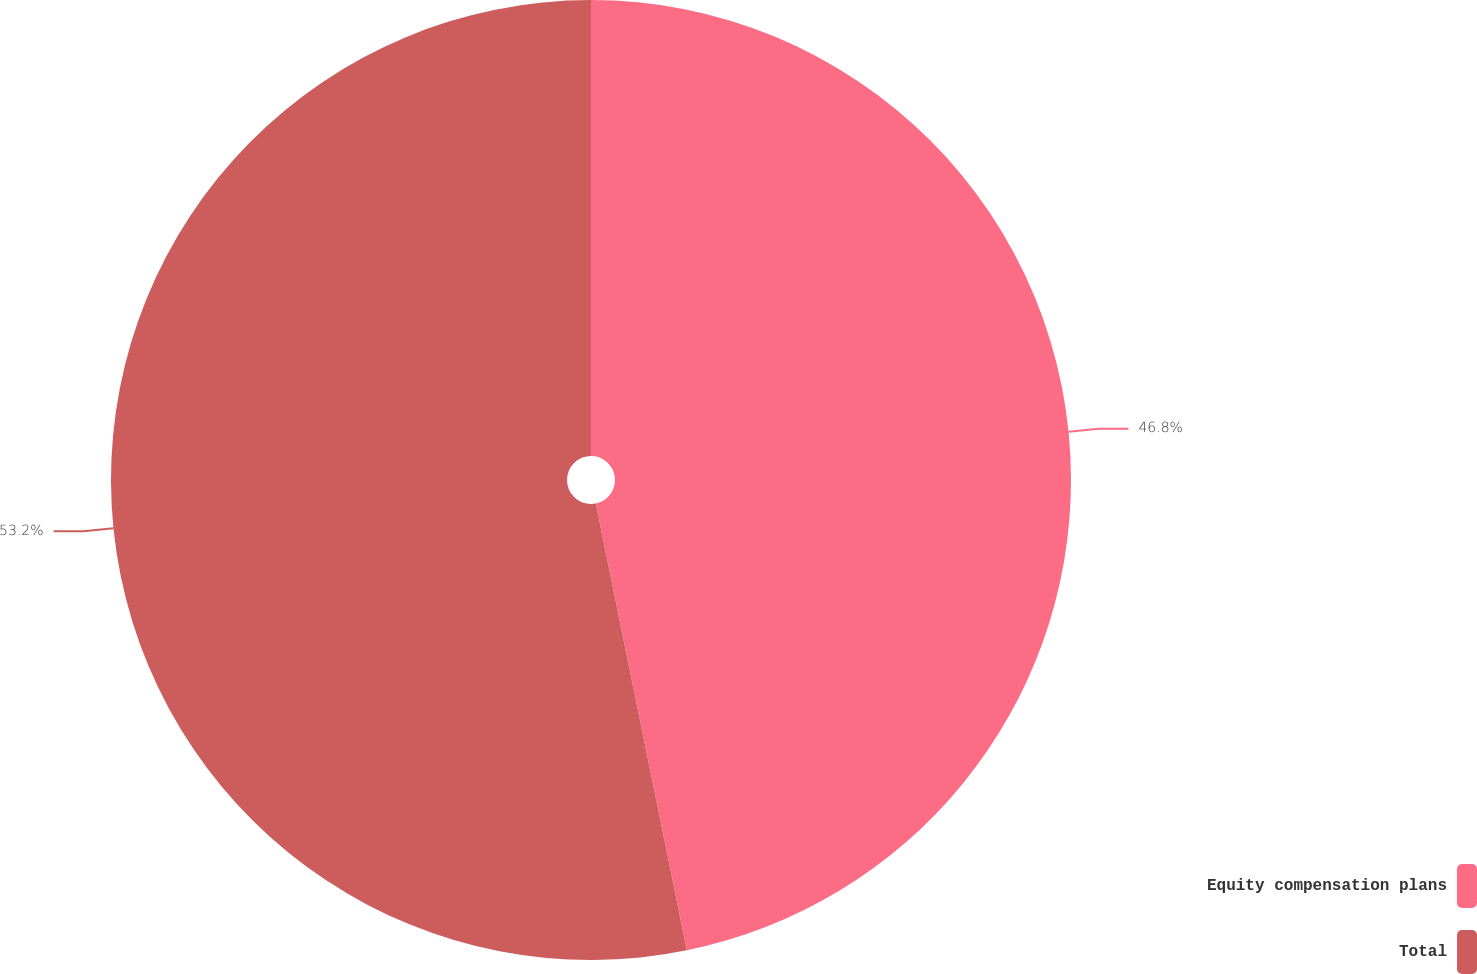Convert chart to OTSL. <chart><loc_0><loc_0><loc_500><loc_500><pie_chart><fcel>Equity compensation plans<fcel>Total<nl><fcel>46.8%<fcel>53.2%<nl></chart> 